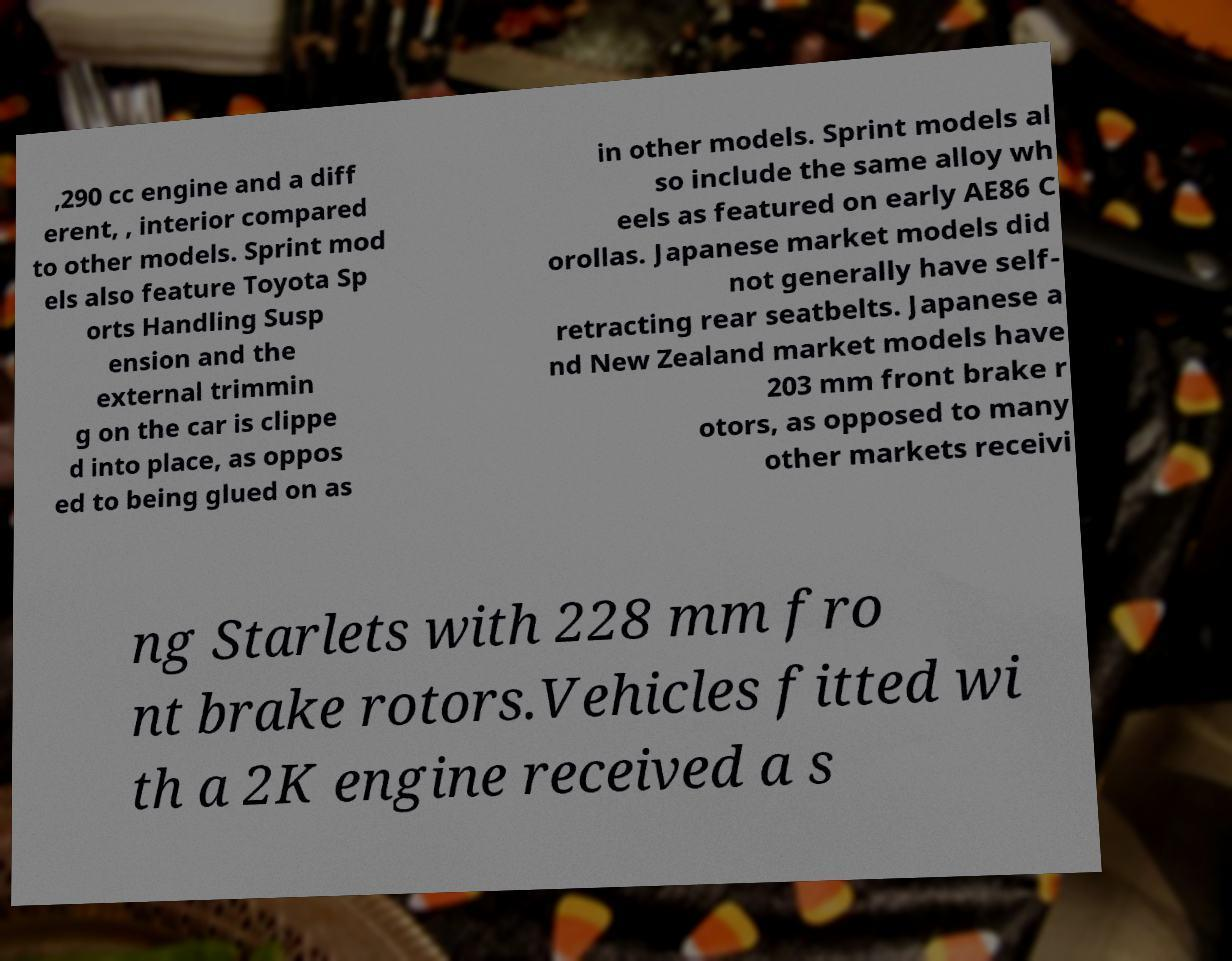There's text embedded in this image that I need extracted. Can you transcribe it verbatim? ,290 cc engine and a diff erent, , interior compared to other models. Sprint mod els also feature Toyota Sp orts Handling Susp ension and the external trimmin g on the car is clippe d into place, as oppos ed to being glued on as in other models. Sprint models al so include the same alloy wh eels as featured on early AE86 C orollas. Japanese market models did not generally have self- retracting rear seatbelts. Japanese a nd New Zealand market models have 203 mm front brake r otors, as opposed to many other markets receivi ng Starlets with 228 mm fro nt brake rotors.Vehicles fitted wi th a 2K engine received a s 